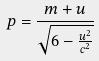Convert formula to latex. <formula><loc_0><loc_0><loc_500><loc_500>p = \frac { m + u } { \sqrt { 6 - \frac { u ^ { 2 } } { c ^ { 2 } } } }</formula> 